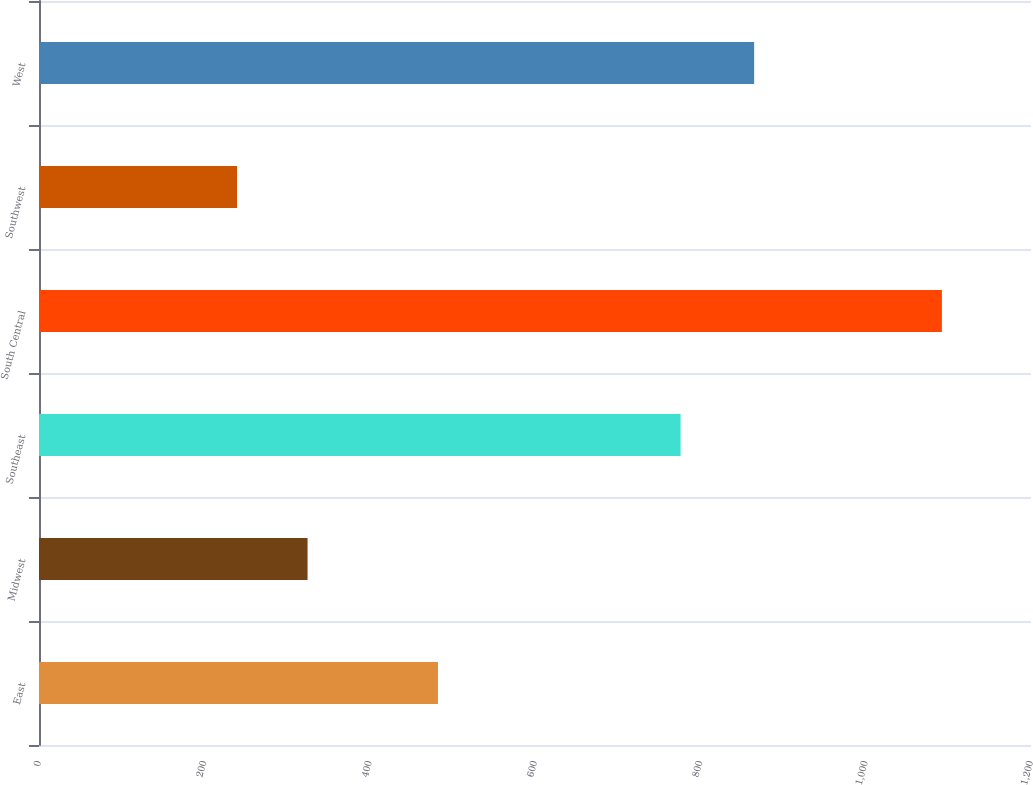Convert chart. <chart><loc_0><loc_0><loc_500><loc_500><bar_chart><fcel>East<fcel>Midwest<fcel>Southeast<fcel>South Central<fcel>Southwest<fcel>West<nl><fcel>482.6<fcel>324.86<fcel>776.1<fcel>1092.2<fcel>239.6<fcel>865.1<nl></chart> 